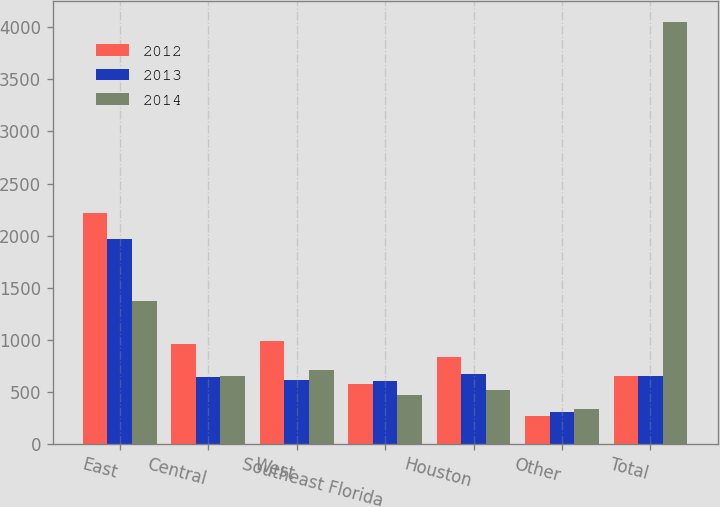<chart> <loc_0><loc_0><loc_500><loc_500><stacked_bar_chart><ecel><fcel>East<fcel>Central<fcel>West<fcel>Southeast Florida<fcel>Houston<fcel>Other<fcel>Total<nl><fcel>2012<fcel>2212<fcel>961<fcel>991<fcel>576<fcel>830<fcel>262<fcel>653<nl><fcel>2013<fcel>1968<fcel>644<fcel>616<fcel>607<fcel>669<fcel>302<fcel>653<nl><fcel>2014<fcel>1376<fcel>653<fcel>708<fcel>469<fcel>516<fcel>331<fcel>4053<nl></chart> 